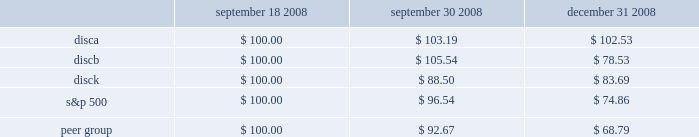2 0 0 8 a n n u a l r e p o r t stock performance graph the following graph sets forth the performance of our series a common , series b common stock , and series c common stock for the period september 18 , 2008 through december 31 , 2008 as compared with the performance of the standard and poor 2019s 500 index and a peer group index which consists of the walt disney company , time warner inc. , cbs corporation class b common stock , viacom , inc .
Class b common stock , news corporation class a common stock , and scripps network interactive , inc .
The graph assumes $ 100 originally invested on september 18 , 2006 and that all subsequent dividends were reinvested in additional shares .
September 18 , september 30 , december 31 , 2008 2008 2008 .
S&p 500 peer group .
Was the c series 2008 annual return greater than the s&p 500? 
Computations: (83.69 > 74.86)
Answer: yes. 2 0 0 8 a n n u a l r e p o r t stock performance graph the following graph sets forth the performance of our series a common , series b common stock , and series c common stock for the period september 18 , 2008 through december 31 , 2008 as compared with the performance of the standard and poor 2019s 500 index and a peer group index which consists of the walt disney company , time warner inc. , cbs corporation class b common stock , viacom , inc .
Class b common stock , news corporation class a common stock , and scripps network interactive , inc .
The graph assumes $ 100 originally invested on september 18 , 2006 and that all subsequent dividends were reinvested in additional shares .
September 18 , september 30 , december 31 , 2008 2008 2008 .
S&p 500 peer group .
What was the percentage cumulative total shareholder return on disca common stock from september 18 , 2008 to december 31 , 2008? 
Computations: ((102.53 - 100) / 100)
Answer: 0.0253. 